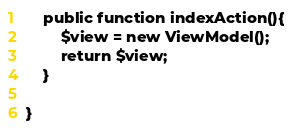Convert code to text. <code><loc_0><loc_0><loc_500><loc_500><_PHP_>	public function indexAction(){
		$view = new ViewModel();
		return $view;
	}

}
</code> 